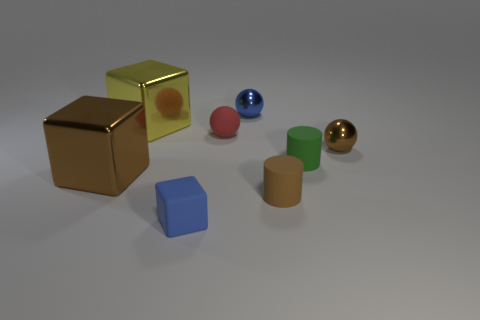Could you tell me what time of day it seems to be in this scene? The lighting in the scene does not indicate a specific time of day; it appears to be a controlled, indoor environment with artificial lighting. 